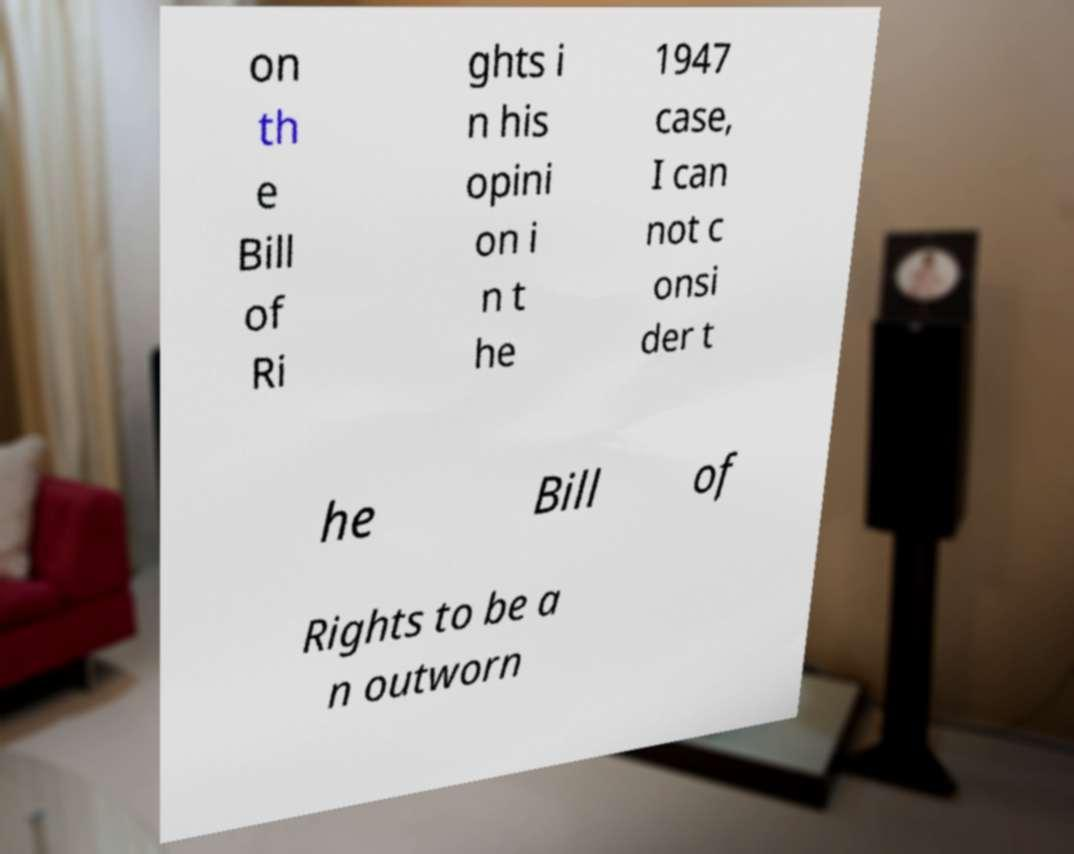There's text embedded in this image that I need extracted. Can you transcribe it verbatim? on th e Bill of Ri ghts i n his opini on i n t he 1947 case, I can not c onsi der t he Bill of Rights to be a n outworn 